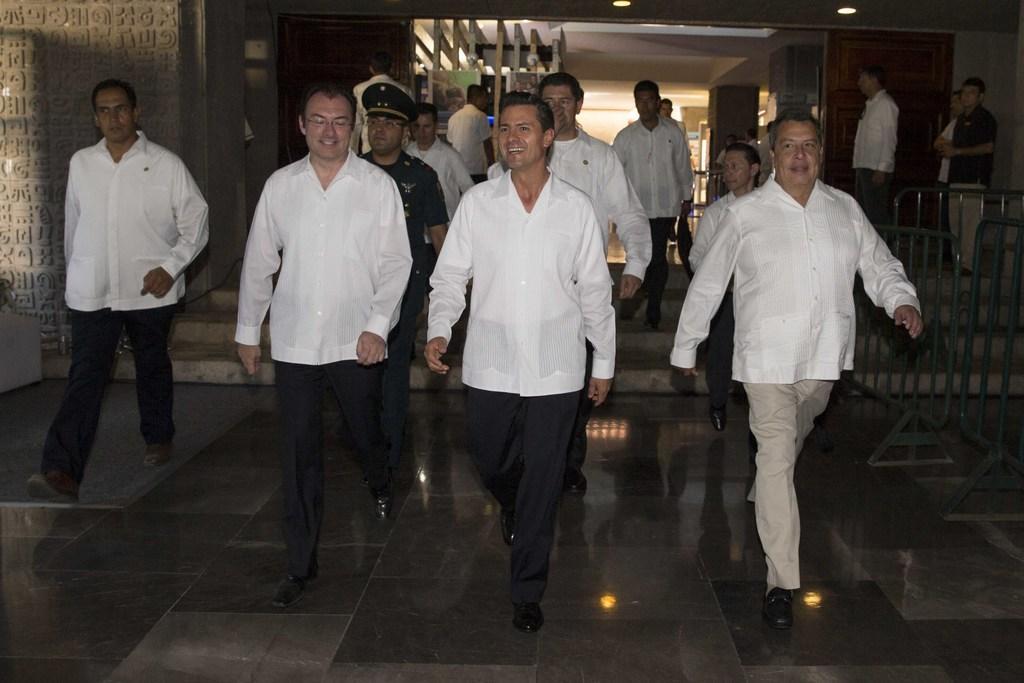In one or two sentences, can you explain what this image depicts? In the image there are many men in white shirt and shoes walking on the floor and behind there is a building with lights inside it and there is a railing on the right side. 